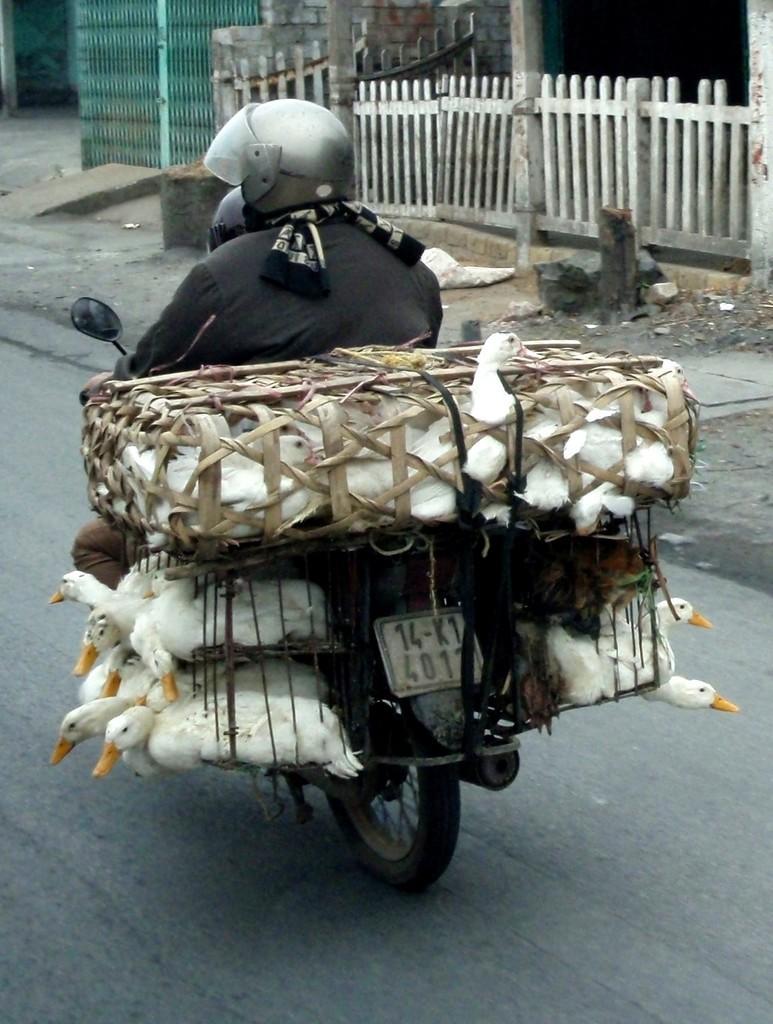Please provide a concise description of this image. In this picture we can see a person riding a bike, on the bike we can see some ducks in a basket, side we can see gates and fence. 